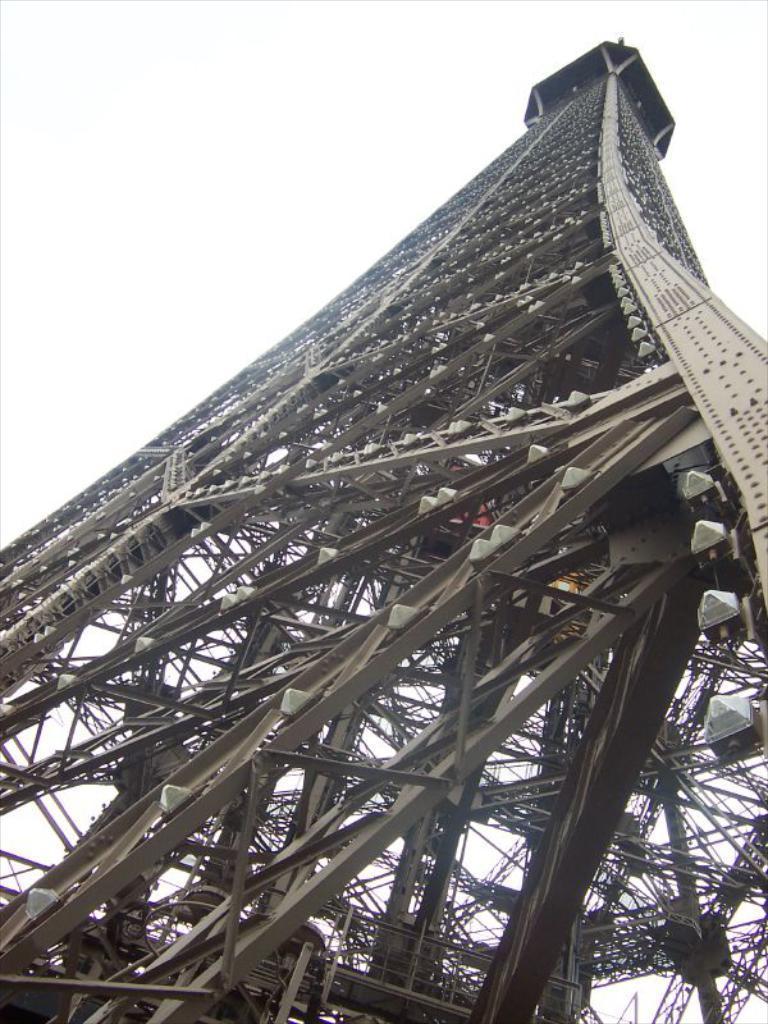How would you summarize this image in a sentence or two? In this image there is a tower which is taken from the bottom. 